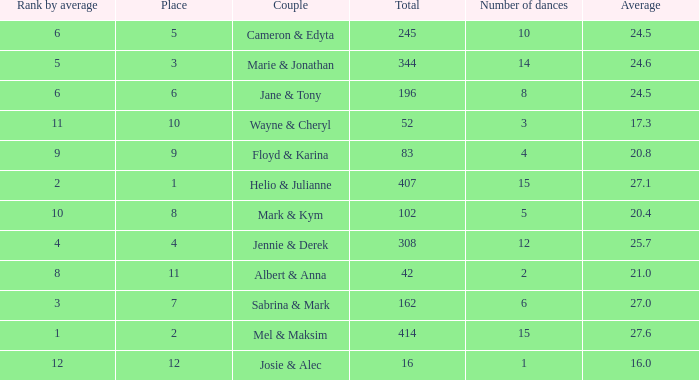What is the average when the rank by average is more than 12? None. 